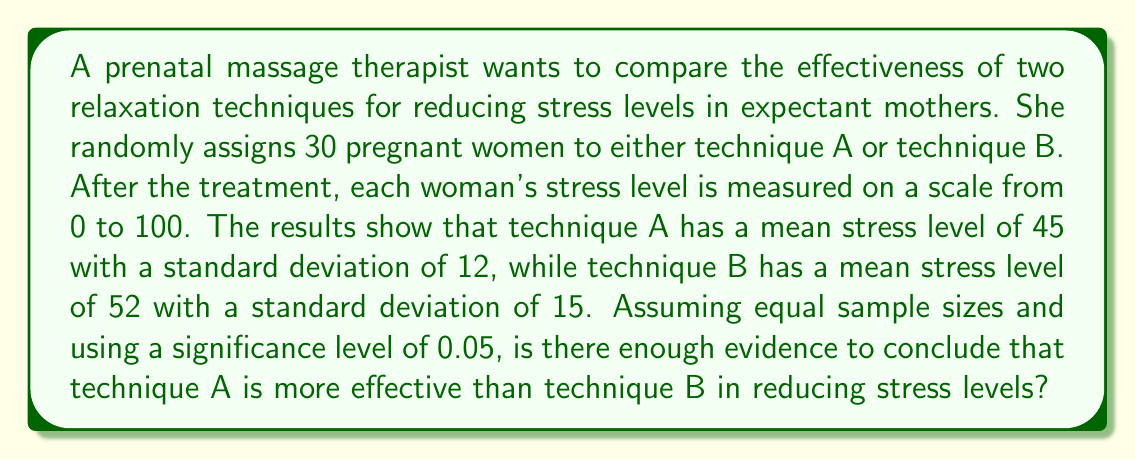Can you solve this math problem? To solve this problem, we'll use a two-sample t-test for independent means. We'll follow these steps:

1) State the hypotheses:
   $H_0: \mu_A = \mu_B$ (null hypothesis)
   $H_a: \mu_A < \mu_B$ (alternative hypothesis, one-tailed test)

2) Calculate the t-statistic:
   $$t = \frac{\bar{X}_A - \bar{X}_B}{\sqrt{\frac{s_A^2}{n_A} + \frac{s_B^2}{n_B}}}$$

   Where:
   $\bar{X}_A = 45$, $\bar{X}_B = 52$
   $s_A = 12$, $s_B = 15$
   $n_A = n_B = 15$ (as total sample size is 30 and equal sample sizes are assumed)

3) Plug in the values:
   $$t = \frac{45 - 52}{\sqrt{\frac{12^2}{15} + \frac{15^2}{15}}} = \frac{-7}{\sqrt{9.6 + 15}} = \frac{-7}{\sqrt{24.6}} = \frac{-7}{4.96} = -1.41$$

4) Calculate degrees of freedom:
   $df = n_A + n_B - 2 = 15 + 15 - 2 = 28$

5) Find the critical t-value:
   For a one-tailed test with $\alpha = 0.05$ and $df = 28$, the critical t-value is approximately -1.701.

6) Compare the calculated t-statistic to the critical t-value:
   $|-1.41| < 1.701$

7) Make a decision:
   Since the absolute value of our calculated t-statistic is less than the critical t-value, we fail to reject the null hypothesis.
Answer: Fail to reject $H_0$; insufficient evidence to conclude technique A is more effective. 